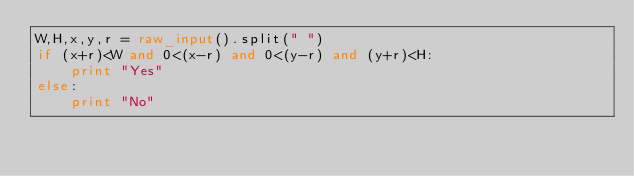<code> <loc_0><loc_0><loc_500><loc_500><_Python_>W,H,x,y,r = raw_input().split(" ")
if (x+r)<W and 0<(x-r) and 0<(y-r) and (y+r)<H:
    print "Yes"
else:
    print "No"</code> 